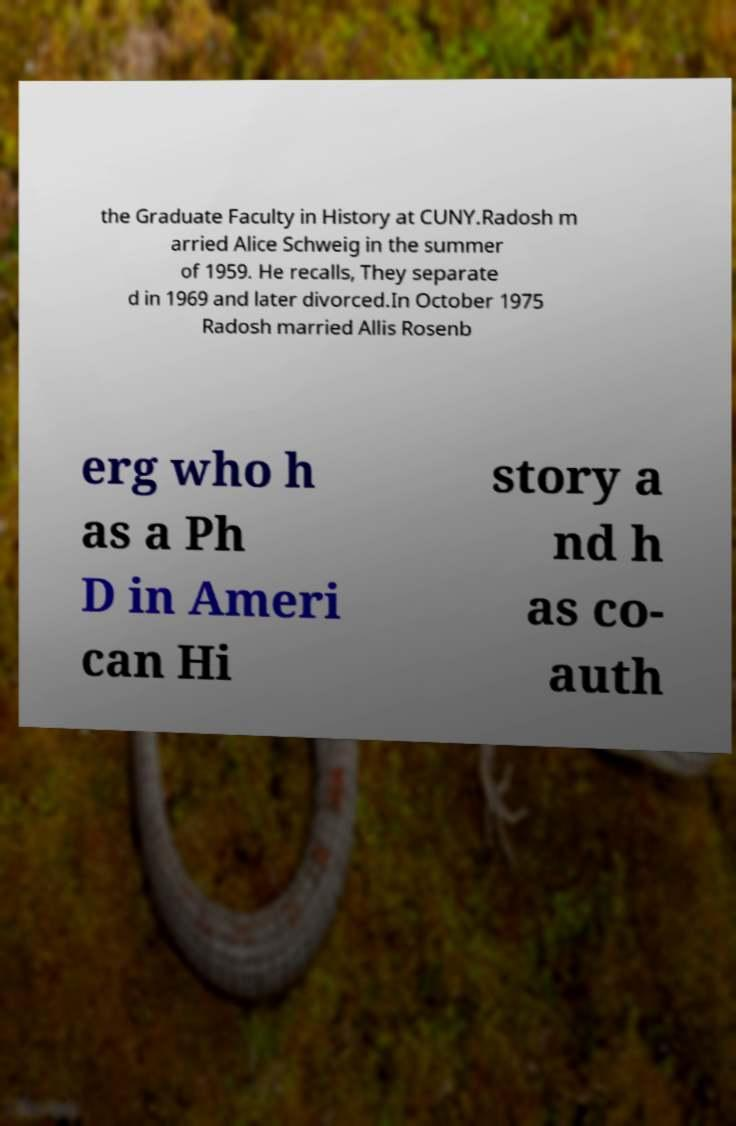Please identify and transcribe the text found in this image. the Graduate Faculty in History at CUNY.Radosh m arried Alice Schweig in the summer of 1959. He recalls, They separate d in 1969 and later divorced.In October 1975 Radosh married Allis Rosenb erg who h as a Ph D in Ameri can Hi story a nd h as co- auth 